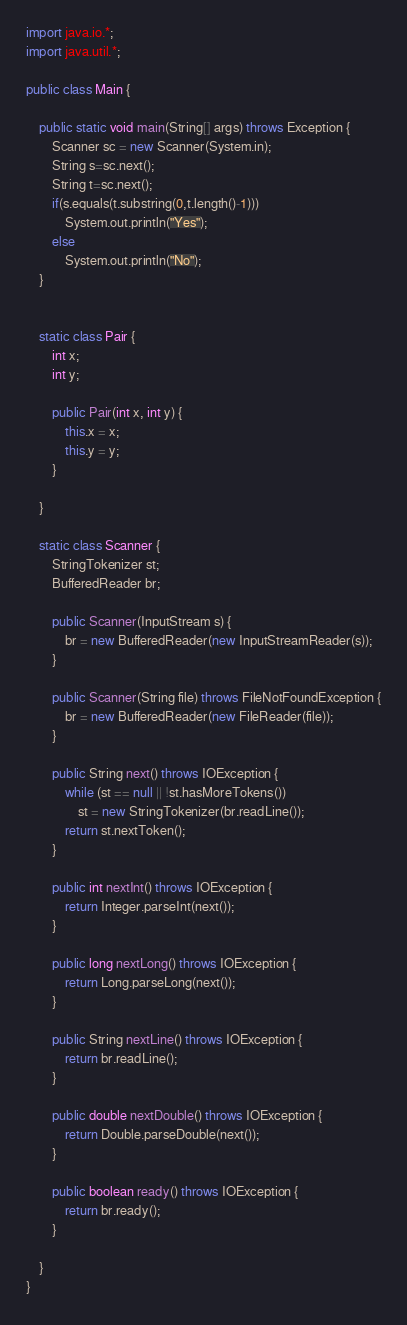<code> <loc_0><loc_0><loc_500><loc_500><_Java_>import java.io.*;
import java.util.*;

public class Main {

	public static void main(String[] args) throws Exception {
		Scanner sc = new Scanner(System.in);
		String s=sc.next();
		String t=sc.next();
		if(s.equals(t.substring(0,t.length()-1)))
			System.out.println("Yes");
		else
			System.out.println("No");
	}


	static class Pair {
		int x;
		int y;

		public Pair(int x, int y) {
			this.x = x;
			this.y = y;
		}

	}

	static class Scanner {
		StringTokenizer st;
		BufferedReader br;

		public Scanner(InputStream s) {
			br = new BufferedReader(new InputStreamReader(s));
		}

		public Scanner(String file) throws FileNotFoundException {
			br = new BufferedReader(new FileReader(file));
		}

		public String next() throws IOException {
			while (st == null || !st.hasMoreTokens())
				st = new StringTokenizer(br.readLine());
			return st.nextToken();
		}

		public int nextInt() throws IOException {
			return Integer.parseInt(next());
		}

		public long nextLong() throws IOException {
			return Long.parseLong(next());
		}

		public String nextLine() throws IOException {
			return br.readLine();
		}

		public double nextDouble() throws IOException {
			return Double.parseDouble(next());
		}

		public boolean ready() throws IOException {
			return br.ready();
		}

	}
}
</code> 